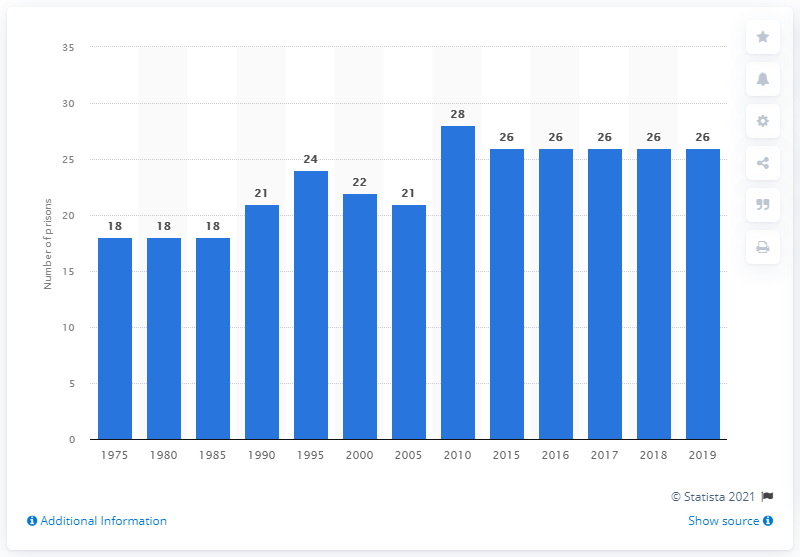Indicate a few pertinent items in this graphic. In 1975, there were 18 prisons in the United States. There were 26 prisons in Finland in 2019. In 2010, there were 28 prisons in Finland. 